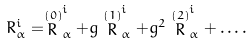<formula> <loc_0><loc_0><loc_500><loc_500>R _ { \alpha } ^ { i } = \stackrel { ( 0 ) } { R } _ { \alpha } ^ { i } + g \stackrel { ( 1 ) } { R } _ { \alpha } ^ { i } + g ^ { 2 } \stackrel { ( 2 ) } { R } _ { \alpha } ^ { i } + \dots .</formula> 